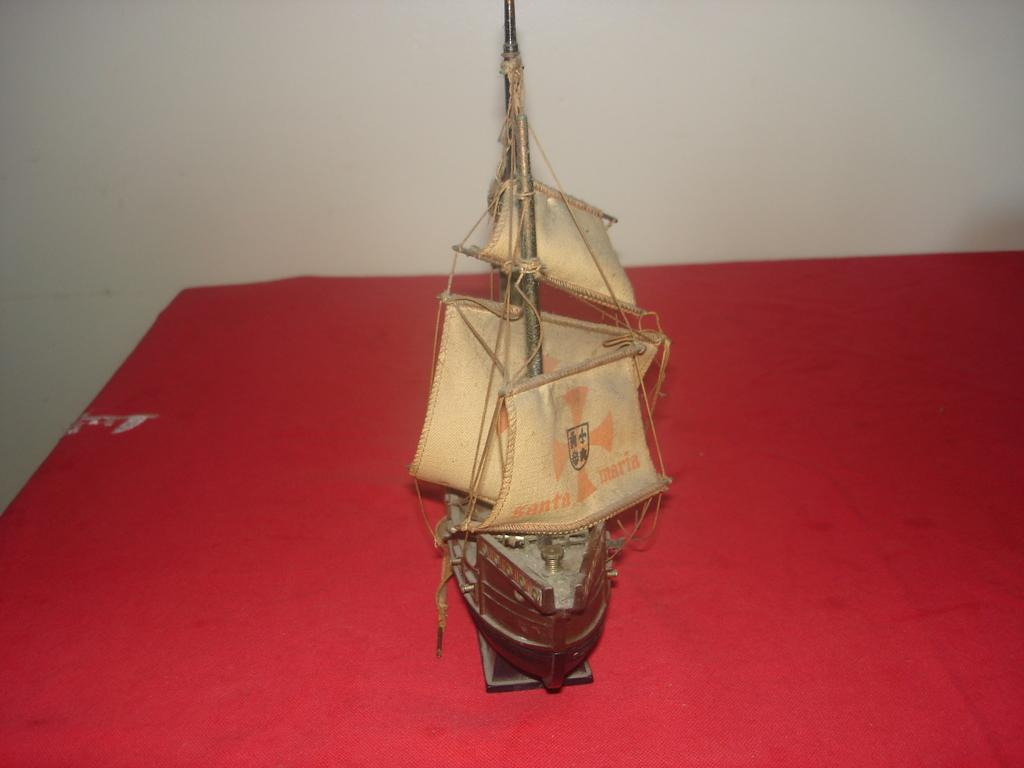What is the main object in the image? There is a ship toy in the image. Where is the ship toy located? The ship toy is kept on a table. What can be seen on the wall in the image? There is a white color wall visible in the image. How many cows are present in the image? There are no cows present in the image; it features a ship toy on a table and a white wall. 